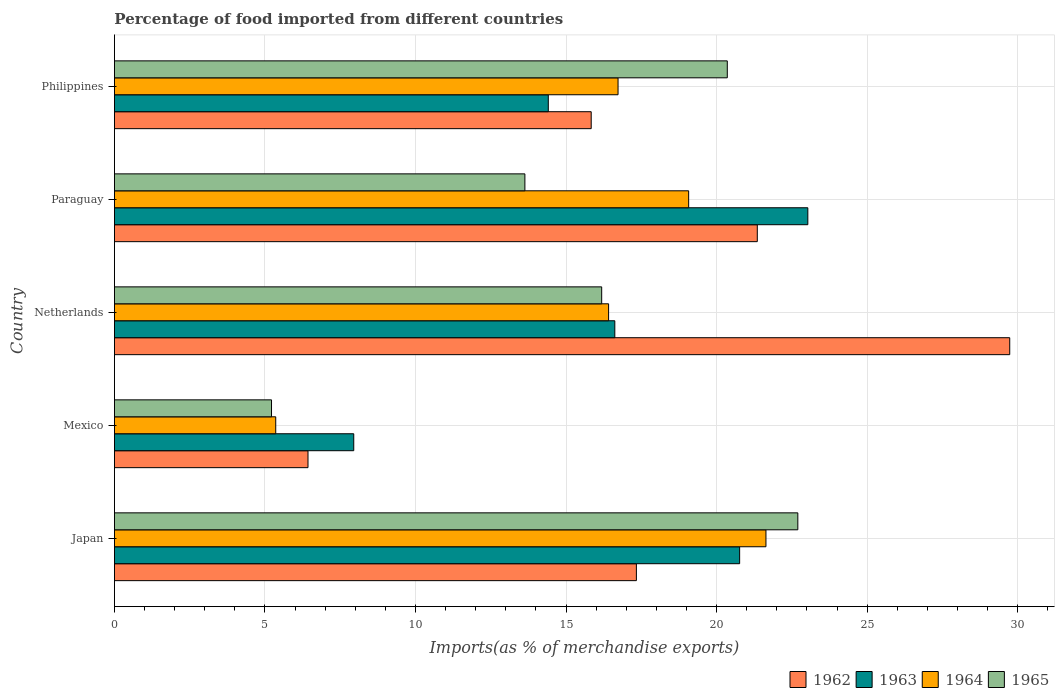How many different coloured bars are there?
Provide a succinct answer. 4. How many bars are there on the 2nd tick from the bottom?
Your response must be concise. 4. What is the label of the 4th group of bars from the top?
Your answer should be compact. Mexico. What is the percentage of imports to different countries in 1962 in Philippines?
Ensure brevity in your answer.  15.83. Across all countries, what is the maximum percentage of imports to different countries in 1965?
Offer a very short reply. 22.7. Across all countries, what is the minimum percentage of imports to different countries in 1965?
Offer a very short reply. 5.22. In which country was the percentage of imports to different countries in 1964 maximum?
Keep it short and to the point. Japan. What is the total percentage of imports to different countries in 1963 in the graph?
Make the answer very short. 82.77. What is the difference between the percentage of imports to different countries in 1964 in Japan and that in Netherlands?
Keep it short and to the point. 5.23. What is the difference between the percentage of imports to different countries in 1962 in Japan and the percentage of imports to different countries in 1965 in Netherlands?
Ensure brevity in your answer.  1.15. What is the average percentage of imports to different countries in 1962 per country?
Make the answer very short. 18.14. What is the difference between the percentage of imports to different countries in 1963 and percentage of imports to different countries in 1962 in Netherlands?
Offer a terse response. -13.12. In how many countries, is the percentage of imports to different countries in 1962 greater than 18 %?
Provide a short and direct response. 2. What is the ratio of the percentage of imports to different countries in 1962 in Japan to that in Mexico?
Provide a succinct answer. 2.7. What is the difference between the highest and the second highest percentage of imports to different countries in 1963?
Ensure brevity in your answer.  2.26. What is the difference between the highest and the lowest percentage of imports to different countries in 1965?
Provide a short and direct response. 17.48. In how many countries, is the percentage of imports to different countries in 1964 greater than the average percentage of imports to different countries in 1964 taken over all countries?
Your response must be concise. 4. Is the sum of the percentage of imports to different countries in 1962 in Japan and Netherlands greater than the maximum percentage of imports to different countries in 1963 across all countries?
Offer a terse response. Yes. Is it the case that in every country, the sum of the percentage of imports to different countries in 1962 and percentage of imports to different countries in 1963 is greater than the sum of percentage of imports to different countries in 1964 and percentage of imports to different countries in 1965?
Keep it short and to the point. No. What does the 2nd bar from the top in Philippines represents?
Provide a short and direct response. 1964. What does the 1st bar from the bottom in Mexico represents?
Provide a short and direct response. 1962. Is it the case that in every country, the sum of the percentage of imports to different countries in 1964 and percentage of imports to different countries in 1963 is greater than the percentage of imports to different countries in 1962?
Your answer should be very brief. Yes. What is the difference between two consecutive major ticks on the X-axis?
Ensure brevity in your answer.  5. Are the values on the major ticks of X-axis written in scientific E-notation?
Offer a terse response. No. Where does the legend appear in the graph?
Your answer should be very brief. Bottom right. How many legend labels are there?
Offer a terse response. 4. What is the title of the graph?
Give a very brief answer. Percentage of food imported from different countries. What is the label or title of the X-axis?
Your answer should be compact. Imports(as % of merchandise exports). What is the Imports(as % of merchandise exports) of 1962 in Japan?
Your answer should be compact. 17.34. What is the Imports(as % of merchandise exports) in 1963 in Japan?
Make the answer very short. 20.76. What is the Imports(as % of merchandise exports) in 1964 in Japan?
Make the answer very short. 21.64. What is the Imports(as % of merchandise exports) in 1965 in Japan?
Your response must be concise. 22.7. What is the Imports(as % of merchandise exports) of 1962 in Mexico?
Make the answer very short. 6.43. What is the Imports(as % of merchandise exports) in 1963 in Mexico?
Give a very brief answer. 7.95. What is the Imports(as % of merchandise exports) of 1964 in Mexico?
Provide a succinct answer. 5.36. What is the Imports(as % of merchandise exports) of 1965 in Mexico?
Your answer should be compact. 5.22. What is the Imports(as % of merchandise exports) in 1962 in Netherlands?
Offer a very short reply. 29.73. What is the Imports(as % of merchandise exports) of 1963 in Netherlands?
Provide a succinct answer. 16.62. What is the Imports(as % of merchandise exports) of 1964 in Netherlands?
Ensure brevity in your answer.  16.41. What is the Imports(as % of merchandise exports) of 1965 in Netherlands?
Offer a terse response. 16.18. What is the Imports(as % of merchandise exports) of 1962 in Paraguay?
Your response must be concise. 21.35. What is the Imports(as % of merchandise exports) of 1963 in Paraguay?
Make the answer very short. 23.03. What is the Imports(as % of merchandise exports) in 1964 in Paraguay?
Provide a short and direct response. 19.07. What is the Imports(as % of merchandise exports) in 1965 in Paraguay?
Give a very brief answer. 13.63. What is the Imports(as % of merchandise exports) of 1962 in Philippines?
Your answer should be compact. 15.83. What is the Imports(as % of merchandise exports) of 1963 in Philippines?
Provide a succinct answer. 14.41. What is the Imports(as % of merchandise exports) of 1964 in Philippines?
Your answer should be very brief. 16.73. What is the Imports(as % of merchandise exports) of 1965 in Philippines?
Keep it short and to the point. 20.35. Across all countries, what is the maximum Imports(as % of merchandise exports) of 1962?
Your answer should be compact. 29.73. Across all countries, what is the maximum Imports(as % of merchandise exports) of 1963?
Make the answer very short. 23.03. Across all countries, what is the maximum Imports(as % of merchandise exports) of 1964?
Give a very brief answer. 21.64. Across all countries, what is the maximum Imports(as % of merchandise exports) of 1965?
Give a very brief answer. 22.7. Across all countries, what is the minimum Imports(as % of merchandise exports) of 1962?
Offer a very short reply. 6.43. Across all countries, what is the minimum Imports(as % of merchandise exports) in 1963?
Provide a short and direct response. 7.95. Across all countries, what is the minimum Imports(as % of merchandise exports) of 1964?
Provide a short and direct response. 5.36. Across all countries, what is the minimum Imports(as % of merchandise exports) in 1965?
Make the answer very short. 5.22. What is the total Imports(as % of merchandise exports) in 1962 in the graph?
Provide a short and direct response. 90.68. What is the total Imports(as % of merchandise exports) in 1963 in the graph?
Offer a very short reply. 82.77. What is the total Imports(as % of merchandise exports) in 1964 in the graph?
Your answer should be compact. 79.21. What is the total Imports(as % of merchandise exports) in 1965 in the graph?
Make the answer very short. 78.08. What is the difference between the Imports(as % of merchandise exports) of 1962 in Japan and that in Mexico?
Ensure brevity in your answer.  10.91. What is the difference between the Imports(as % of merchandise exports) in 1963 in Japan and that in Mexico?
Ensure brevity in your answer.  12.82. What is the difference between the Imports(as % of merchandise exports) of 1964 in Japan and that in Mexico?
Give a very brief answer. 16.28. What is the difference between the Imports(as % of merchandise exports) in 1965 in Japan and that in Mexico?
Offer a very short reply. 17.48. What is the difference between the Imports(as % of merchandise exports) in 1962 in Japan and that in Netherlands?
Make the answer very short. -12.4. What is the difference between the Imports(as % of merchandise exports) in 1963 in Japan and that in Netherlands?
Offer a very short reply. 4.15. What is the difference between the Imports(as % of merchandise exports) of 1964 in Japan and that in Netherlands?
Provide a short and direct response. 5.23. What is the difference between the Imports(as % of merchandise exports) of 1965 in Japan and that in Netherlands?
Offer a terse response. 6.51. What is the difference between the Imports(as % of merchandise exports) in 1962 in Japan and that in Paraguay?
Provide a short and direct response. -4.02. What is the difference between the Imports(as % of merchandise exports) of 1963 in Japan and that in Paraguay?
Provide a short and direct response. -2.26. What is the difference between the Imports(as % of merchandise exports) of 1964 in Japan and that in Paraguay?
Make the answer very short. 2.57. What is the difference between the Imports(as % of merchandise exports) of 1965 in Japan and that in Paraguay?
Make the answer very short. 9.06. What is the difference between the Imports(as % of merchandise exports) in 1962 in Japan and that in Philippines?
Give a very brief answer. 1.5. What is the difference between the Imports(as % of merchandise exports) of 1963 in Japan and that in Philippines?
Your answer should be compact. 6.35. What is the difference between the Imports(as % of merchandise exports) in 1964 in Japan and that in Philippines?
Give a very brief answer. 4.91. What is the difference between the Imports(as % of merchandise exports) of 1965 in Japan and that in Philippines?
Offer a very short reply. 2.34. What is the difference between the Imports(as % of merchandise exports) of 1962 in Mexico and that in Netherlands?
Provide a short and direct response. -23.31. What is the difference between the Imports(as % of merchandise exports) of 1963 in Mexico and that in Netherlands?
Provide a short and direct response. -8.67. What is the difference between the Imports(as % of merchandise exports) in 1964 in Mexico and that in Netherlands?
Ensure brevity in your answer.  -11.05. What is the difference between the Imports(as % of merchandise exports) of 1965 in Mexico and that in Netherlands?
Your answer should be very brief. -10.97. What is the difference between the Imports(as % of merchandise exports) of 1962 in Mexico and that in Paraguay?
Provide a succinct answer. -14.92. What is the difference between the Imports(as % of merchandise exports) in 1963 in Mexico and that in Paraguay?
Your answer should be very brief. -15.08. What is the difference between the Imports(as % of merchandise exports) of 1964 in Mexico and that in Paraguay?
Make the answer very short. -13.71. What is the difference between the Imports(as % of merchandise exports) in 1965 in Mexico and that in Paraguay?
Make the answer very short. -8.42. What is the difference between the Imports(as % of merchandise exports) in 1962 in Mexico and that in Philippines?
Provide a short and direct response. -9.41. What is the difference between the Imports(as % of merchandise exports) of 1963 in Mexico and that in Philippines?
Keep it short and to the point. -6.46. What is the difference between the Imports(as % of merchandise exports) of 1964 in Mexico and that in Philippines?
Keep it short and to the point. -11.37. What is the difference between the Imports(as % of merchandise exports) in 1965 in Mexico and that in Philippines?
Your answer should be very brief. -15.14. What is the difference between the Imports(as % of merchandise exports) in 1962 in Netherlands and that in Paraguay?
Provide a short and direct response. 8.38. What is the difference between the Imports(as % of merchandise exports) in 1963 in Netherlands and that in Paraguay?
Provide a succinct answer. -6.41. What is the difference between the Imports(as % of merchandise exports) in 1964 in Netherlands and that in Paraguay?
Provide a succinct answer. -2.66. What is the difference between the Imports(as % of merchandise exports) of 1965 in Netherlands and that in Paraguay?
Provide a short and direct response. 2.55. What is the difference between the Imports(as % of merchandise exports) in 1962 in Netherlands and that in Philippines?
Your response must be concise. 13.9. What is the difference between the Imports(as % of merchandise exports) of 1963 in Netherlands and that in Philippines?
Offer a very short reply. 2.21. What is the difference between the Imports(as % of merchandise exports) in 1964 in Netherlands and that in Philippines?
Ensure brevity in your answer.  -0.31. What is the difference between the Imports(as % of merchandise exports) in 1965 in Netherlands and that in Philippines?
Provide a succinct answer. -4.17. What is the difference between the Imports(as % of merchandise exports) in 1962 in Paraguay and that in Philippines?
Ensure brevity in your answer.  5.52. What is the difference between the Imports(as % of merchandise exports) of 1963 in Paraguay and that in Philippines?
Keep it short and to the point. 8.62. What is the difference between the Imports(as % of merchandise exports) in 1964 in Paraguay and that in Philippines?
Provide a short and direct response. 2.35. What is the difference between the Imports(as % of merchandise exports) in 1965 in Paraguay and that in Philippines?
Give a very brief answer. -6.72. What is the difference between the Imports(as % of merchandise exports) of 1962 in Japan and the Imports(as % of merchandise exports) of 1963 in Mexico?
Your answer should be very brief. 9.39. What is the difference between the Imports(as % of merchandise exports) of 1962 in Japan and the Imports(as % of merchandise exports) of 1964 in Mexico?
Provide a short and direct response. 11.98. What is the difference between the Imports(as % of merchandise exports) in 1962 in Japan and the Imports(as % of merchandise exports) in 1965 in Mexico?
Offer a very short reply. 12.12. What is the difference between the Imports(as % of merchandise exports) in 1963 in Japan and the Imports(as % of merchandise exports) in 1964 in Mexico?
Provide a short and direct response. 15.41. What is the difference between the Imports(as % of merchandise exports) of 1963 in Japan and the Imports(as % of merchandise exports) of 1965 in Mexico?
Keep it short and to the point. 15.55. What is the difference between the Imports(as % of merchandise exports) in 1964 in Japan and the Imports(as % of merchandise exports) in 1965 in Mexico?
Your response must be concise. 16.42. What is the difference between the Imports(as % of merchandise exports) of 1962 in Japan and the Imports(as % of merchandise exports) of 1963 in Netherlands?
Offer a terse response. 0.72. What is the difference between the Imports(as % of merchandise exports) of 1962 in Japan and the Imports(as % of merchandise exports) of 1964 in Netherlands?
Your answer should be very brief. 0.92. What is the difference between the Imports(as % of merchandise exports) in 1962 in Japan and the Imports(as % of merchandise exports) in 1965 in Netherlands?
Offer a terse response. 1.15. What is the difference between the Imports(as % of merchandise exports) of 1963 in Japan and the Imports(as % of merchandise exports) of 1964 in Netherlands?
Provide a short and direct response. 4.35. What is the difference between the Imports(as % of merchandise exports) of 1963 in Japan and the Imports(as % of merchandise exports) of 1965 in Netherlands?
Provide a succinct answer. 4.58. What is the difference between the Imports(as % of merchandise exports) in 1964 in Japan and the Imports(as % of merchandise exports) in 1965 in Netherlands?
Make the answer very short. 5.46. What is the difference between the Imports(as % of merchandise exports) in 1962 in Japan and the Imports(as % of merchandise exports) in 1963 in Paraguay?
Ensure brevity in your answer.  -5.69. What is the difference between the Imports(as % of merchandise exports) of 1962 in Japan and the Imports(as % of merchandise exports) of 1964 in Paraguay?
Give a very brief answer. -1.74. What is the difference between the Imports(as % of merchandise exports) of 1962 in Japan and the Imports(as % of merchandise exports) of 1965 in Paraguay?
Ensure brevity in your answer.  3.7. What is the difference between the Imports(as % of merchandise exports) in 1963 in Japan and the Imports(as % of merchandise exports) in 1964 in Paraguay?
Your answer should be very brief. 1.69. What is the difference between the Imports(as % of merchandise exports) in 1963 in Japan and the Imports(as % of merchandise exports) in 1965 in Paraguay?
Offer a very short reply. 7.13. What is the difference between the Imports(as % of merchandise exports) of 1964 in Japan and the Imports(as % of merchandise exports) of 1965 in Paraguay?
Ensure brevity in your answer.  8.01. What is the difference between the Imports(as % of merchandise exports) in 1962 in Japan and the Imports(as % of merchandise exports) in 1963 in Philippines?
Offer a very short reply. 2.93. What is the difference between the Imports(as % of merchandise exports) in 1962 in Japan and the Imports(as % of merchandise exports) in 1964 in Philippines?
Offer a terse response. 0.61. What is the difference between the Imports(as % of merchandise exports) of 1962 in Japan and the Imports(as % of merchandise exports) of 1965 in Philippines?
Give a very brief answer. -3.02. What is the difference between the Imports(as % of merchandise exports) in 1963 in Japan and the Imports(as % of merchandise exports) in 1964 in Philippines?
Ensure brevity in your answer.  4.04. What is the difference between the Imports(as % of merchandise exports) of 1963 in Japan and the Imports(as % of merchandise exports) of 1965 in Philippines?
Provide a short and direct response. 0.41. What is the difference between the Imports(as % of merchandise exports) of 1964 in Japan and the Imports(as % of merchandise exports) of 1965 in Philippines?
Ensure brevity in your answer.  1.28. What is the difference between the Imports(as % of merchandise exports) of 1962 in Mexico and the Imports(as % of merchandise exports) of 1963 in Netherlands?
Provide a succinct answer. -10.19. What is the difference between the Imports(as % of merchandise exports) of 1962 in Mexico and the Imports(as % of merchandise exports) of 1964 in Netherlands?
Your response must be concise. -9.98. What is the difference between the Imports(as % of merchandise exports) of 1962 in Mexico and the Imports(as % of merchandise exports) of 1965 in Netherlands?
Give a very brief answer. -9.75. What is the difference between the Imports(as % of merchandise exports) of 1963 in Mexico and the Imports(as % of merchandise exports) of 1964 in Netherlands?
Ensure brevity in your answer.  -8.46. What is the difference between the Imports(as % of merchandise exports) of 1963 in Mexico and the Imports(as % of merchandise exports) of 1965 in Netherlands?
Provide a short and direct response. -8.23. What is the difference between the Imports(as % of merchandise exports) in 1964 in Mexico and the Imports(as % of merchandise exports) in 1965 in Netherlands?
Ensure brevity in your answer.  -10.83. What is the difference between the Imports(as % of merchandise exports) in 1962 in Mexico and the Imports(as % of merchandise exports) in 1963 in Paraguay?
Provide a succinct answer. -16.6. What is the difference between the Imports(as % of merchandise exports) of 1962 in Mexico and the Imports(as % of merchandise exports) of 1964 in Paraguay?
Keep it short and to the point. -12.64. What is the difference between the Imports(as % of merchandise exports) of 1962 in Mexico and the Imports(as % of merchandise exports) of 1965 in Paraguay?
Ensure brevity in your answer.  -7.2. What is the difference between the Imports(as % of merchandise exports) of 1963 in Mexico and the Imports(as % of merchandise exports) of 1964 in Paraguay?
Make the answer very short. -11.12. What is the difference between the Imports(as % of merchandise exports) in 1963 in Mexico and the Imports(as % of merchandise exports) in 1965 in Paraguay?
Your answer should be very brief. -5.68. What is the difference between the Imports(as % of merchandise exports) of 1964 in Mexico and the Imports(as % of merchandise exports) of 1965 in Paraguay?
Your answer should be compact. -8.27. What is the difference between the Imports(as % of merchandise exports) in 1962 in Mexico and the Imports(as % of merchandise exports) in 1963 in Philippines?
Offer a terse response. -7.98. What is the difference between the Imports(as % of merchandise exports) in 1962 in Mexico and the Imports(as % of merchandise exports) in 1964 in Philippines?
Your response must be concise. -10.3. What is the difference between the Imports(as % of merchandise exports) in 1962 in Mexico and the Imports(as % of merchandise exports) in 1965 in Philippines?
Keep it short and to the point. -13.93. What is the difference between the Imports(as % of merchandise exports) in 1963 in Mexico and the Imports(as % of merchandise exports) in 1964 in Philippines?
Your answer should be very brief. -8.78. What is the difference between the Imports(as % of merchandise exports) of 1963 in Mexico and the Imports(as % of merchandise exports) of 1965 in Philippines?
Ensure brevity in your answer.  -12.41. What is the difference between the Imports(as % of merchandise exports) of 1964 in Mexico and the Imports(as % of merchandise exports) of 1965 in Philippines?
Offer a terse response. -15. What is the difference between the Imports(as % of merchandise exports) in 1962 in Netherlands and the Imports(as % of merchandise exports) in 1963 in Paraguay?
Keep it short and to the point. 6.71. What is the difference between the Imports(as % of merchandise exports) of 1962 in Netherlands and the Imports(as % of merchandise exports) of 1964 in Paraguay?
Keep it short and to the point. 10.66. What is the difference between the Imports(as % of merchandise exports) in 1962 in Netherlands and the Imports(as % of merchandise exports) in 1965 in Paraguay?
Provide a succinct answer. 16.1. What is the difference between the Imports(as % of merchandise exports) of 1963 in Netherlands and the Imports(as % of merchandise exports) of 1964 in Paraguay?
Provide a succinct answer. -2.45. What is the difference between the Imports(as % of merchandise exports) of 1963 in Netherlands and the Imports(as % of merchandise exports) of 1965 in Paraguay?
Provide a succinct answer. 2.99. What is the difference between the Imports(as % of merchandise exports) in 1964 in Netherlands and the Imports(as % of merchandise exports) in 1965 in Paraguay?
Offer a very short reply. 2.78. What is the difference between the Imports(as % of merchandise exports) of 1962 in Netherlands and the Imports(as % of merchandise exports) of 1963 in Philippines?
Your answer should be very brief. 15.32. What is the difference between the Imports(as % of merchandise exports) of 1962 in Netherlands and the Imports(as % of merchandise exports) of 1964 in Philippines?
Your answer should be very brief. 13.01. What is the difference between the Imports(as % of merchandise exports) of 1962 in Netherlands and the Imports(as % of merchandise exports) of 1965 in Philippines?
Your answer should be very brief. 9.38. What is the difference between the Imports(as % of merchandise exports) in 1963 in Netherlands and the Imports(as % of merchandise exports) in 1964 in Philippines?
Make the answer very short. -0.11. What is the difference between the Imports(as % of merchandise exports) in 1963 in Netherlands and the Imports(as % of merchandise exports) in 1965 in Philippines?
Provide a short and direct response. -3.74. What is the difference between the Imports(as % of merchandise exports) in 1964 in Netherlands and the Imports(as % of merchandise exports) in 1965 in Philippines?
Keep it short and to the point. -3.94. What is the difference between the Imports(as % of merchandise exports) in 1962 in Paraguay and the Imports(as % of merchandise exports) in 1963 in Philippines?
Keep it short and to the point. 6.94. What is the difference between the Imports(as % of merchandise exports) of 1962 in Paraguay and the Imports(as % of merchandise exports) of 1964 in Philippines?
Your answer should be very brief. 4.62. What is the difference between the Imports(as % of merchandise exports) in 1963 in Paraguay and the Imports(as % of merchandise exports) in 1964 in Philippines?
Ensure brevity in your answer.  6.3. What is the difference between the Imports(as % of merchandise exports) of 1963 in Paraguay and the Imports(as % of merchandise exports) of 1965 in Philippines?
Offer a terse response. 2.67. What is the difference between the Imports(as % of merchandise exports) in 1964 in Paraguay and the Imports(as % of merchandise exports) in 1965 in Philippines?
Provide a short and direct response. -1.28. What is the average Imports(as % of merchandise exports) in 1962 per country?
Provide a succinct answer. 18.14. What is the average Imports(as % of merchandise exports) of 1963 per country?
Your answer should be compact. 16.55. What is the average Imports(as % of merchandise exports) of 1964 per country?
Your answer should be compact. 15.84. What is the average Imports(as % of merchandise exports) of 1965 per country?
Offer a very short reply. 15.62. What is the difference between the Imports(as % of merchandise exports) in 1962 and Imports(as % of merchandise exports) in 1963 in Japan?
Offer a very short reply. -3.43. What is the difference between the Imports(as % of merchandise exports) in 1962 and Imports(as % of merchandise exports) in 1964 in Japan?
Your answer should be compact. -4.3. What is the difference between the Imports(as % of merchandise exports) in 1962 and Imports(as % of merchandise exports) in 1965 in Japan?
Offer a very short reply. -5.36. What is the difference between the Imports(as % of merchandise exports) of 1963 and Imports(as % of merchandise exports) of 1964 in Japan?
Provide a succinct answer. -0.87. What is the difference between the Imports(as % of merchandise exports) of 1963 and Imports(as % of merchandise exports) of 1965 in Japan?
Offer a very short reply. -1.93. What is the difference between the Imports(as % of merchandise exports) in 1964 and Imports(as % of merchandise exports) in 1965 in Japan?
Keep it short and to the point. -1.06. What is the difference between the Imports(as % of merchandise exports) of 1962 and Imports(as % of merchandise exports) of 1963 in Mexico?
Offer a terse response. -1.52. What is the difference between the Imports(as % of merchandise exports) of 1962 and Imports(as % of merchandise exports) of 1964 in Mexico?
Your answer should be compact. 1.07. What is the difference between the Imports(as % of merchandise exports) in 1962 and Imports(as % of merchandise exports) in 1965 in Mexico?
Offer a very short reply. 1.21. What is the difference between the Imports(as % of merchandise exports) of 1963 and Imports(as % of merchandise exports) of 1964 in Mexico?
Ensure brevity in your answer.  2.59. What is the difference between the Imports(as % of merchandise exports) in 1963 and Imports(as % of merchandise exports) in 1965 in Mexico?
Keep it short and to the point. 2.73. What is the difference between the Imports(as % of merchandise exports) of 1964 and Imports(as % of merchandise exports) of 1965 in Mexico?
Your answer should be very brief. 0.14. What is the difference between the Imports(as % of merchandise exports) of 1962 and Imports(as % of merchandise exports) of 1963 in Netherlands?
Ensure brevity in your answer.  13.12. What is the difference between the Imports(as % of merchandise exports) in 1962 and Imports(as % of merchandise exports) in 1964 in Netherlands?
Keep it short and to the point. 13.32. What is the difference between the Imports(as % of merchandise exports) in 1962 and Imports(as % of merchandise exports) in 1965 in Netherlands?
Offer a very short reply. 13.55. What is the difference between the Imports(as % of merchandise exports) in 1963 and Imports(as % of merchandise exports) in 1964 in Netherlands?
Ensure brevity in your answer.  0.21. What is the difference between the Imports(as % of merchandise exports) in 1963 and Imports(as % of merchandise exports) in 1965 in Netherlands?
Offer a very short reply. 0.44. What is the difference between the Imports(as % of merchandise exports) in 1964 and Imports(as % of merchandise exports) in 1965 in Netherlands?
Your answer should be very brief. 0.23. What is the difference between the Imports(as % of merchandise exports) of 1962 and Imports(as % of merchandise exports) of 1963 in Paraguay?
Offer a terse response. -1.68. What is the difference between the Imports(as % of merchandise exports) of 1962 and Imports(as % of merchandise exports) of 1964 in Paraguay?
Offer a terse response. 2.28. What is the difference between the Imports(as % of merchandise exports) of 1962 and Imports(as % of merchandise exports) of 1965 in Paraguay?
Provide a succinct answer. 7.72. What is the difference between the Imports(as % of merchandise exports) of 1963 and Imports(as % of merchandise exports) of 1964 in Paraguay?
Give a very brief answer. 3.96. What is the difference between the Imports(as % of merchandise exports) in 1963 and Imports(as % of merchandise exports) in 1965 in Paraguay?
Make the answer very short. 9.4. What is the difference between the Imports(as % of merchandise exports) in 1964 and Imports(as % of merchandise exports) in 1965 in Paraguay?
Keep it short and to the point. 5.44. What is the difference between the Imports(as % of merchandise exports) of 1962 and Imports(as % of merchandise exports) of 1963 in Philippines?
Your response must be concise. 1.43. What is the difference between the Imports(as % of merchandise exports) of 1962 and Imports(as % of merchandise exports) of 1964 in Philippines?
Offer a terse response. -0.89. What is the difference between the Imports(as % of merchandise exports) in 1962 and Imports(as % of merchandise exports) in 1965 in Philippines?
Your answer should be compact. -4.52. What is the difference between the Imports(as % of merchandise exports) of 1963 and Imports(as % of merchandise exports) of 1964 in Philippines?
Offer a very short reply. -2.32. What is the difference between the Imports(as % of merchandise exports) of 1963 and Imports(as % of merchandise exports) of 1965 in Philippines?
Your response must be concise. -5.94. What is the difference between the Imports(as % of merchandise exports) in 1964 and Imports(as % of merchandise exports) in 1965 in Philippines?
Give a very brief answer. -3.63. What is the ratio of the Imports(as % of merchandise exports) of 1962 in Japan to that in Mexico?
Give a very brief answer. 2.7. What is the ratio of the Imports(as % of merchandise exports) in 1963 in Japan to that in Mexico?
Offer a terse response. 2.61. What is the ratio of the Imports(as % of merchandise exports) of 1964 in Japan to that in Mexico?
Provide a succinct answer. 4.04. What is the ratio of the Imports(as % of merchandise exports) in 1965 in Japan to that in Mexico?
Make the answer very short. 4.35. What is the ratio of the Imports(as % of merchandise exports) in 1962 in Japan to that in Netherlands?
Your answer should be very brief. 0.58. What is the ratio of the Imports(as % of merchandise exports) in 1963 in Japan to that in Netherlands?
Your response must be concise. 1.25. What is the ratio of the Imports(as % of merchandise exports) of 1964 in Japan to that in Netherlands?
Offer a terse response. 1.32. What is the ratio of the Imports(as % of merchandise exports) of 1965 in Japan to that in Netherlands?
Provide a succinct answer. 1.4. What is the ratio of the Imports(as % of merchandise exports) of 1962 in Japan to that in Paraguay?
Keep it short and to the point. 0.81. What is the ratio of the Imports(as % of merchandise exports) of 1963 in Japan to that in Paraguay?
Offer a terse response. 0.9. What is the ratio of the Imports(as % of merchandise exports) of 1964 in Japan to that in Paraguay?
Offer a terse response. 1.13. What is the ratio of the Imports(as % of merchandise exports) of 1965 in Japan to that in Paraguay?
Your response must be concise. 1.67. What is the ratio of the Imports(as % of merchandise exports) in 1962 in Japan to that in Philippines?
Your response must be concise. 1.09. What is the ratio of the Imports(as % of merchandise exports) in 1963 in Japan to that in Philippines?
Make the answer very short. 1.44. What is the ratio of the Imports(as % of merchandise exports) in 1964 in Japan to that in Philippines?
Provide a short and direct response. 1.29. What is the ratio of the Imports(as % of merchandise exports) in 1965 in Japan to that in Philippines?
Offer a terse response. 1.12. What is the ratio of the Imports(as % of merchandise exports) in 1962 in Mexico to that in Netherlands?
Your answer should be compact. 0.22. What is the ratio of the Imports(as % of merchandise exports) of 1963 in Mexico to that in Netherlands?
Provide a short and direct response. 0.48. What is the ratio of the Imports(as % of merchandise exports) in 1964 in Mexico to that in Netherlands?
Offer a terse response. 0.33. What is the ratio of the Imports(as % of merchandise exports) in 1965 in Mexico to that in Netherlands?
Offer a very short reply. 0.32. What is the ratio of the Imports(as % of merchandise exports) in 1962 in Mexico to that in Paraguay?
Your response must be concise. 0.3. What is the ratio of the Imports(as % of merchandise exports) in 1963 in Mexico to that in Paraguay?
Give a very brief answer. 0.35. What is the ratio of the Imports(as % of merchandise exports) of 1964 in Mexico to that in Paraguay?
Give a very brief answer. 0.28. What is the ratio of the Imports(as % of merchandise exports) of 1965 in Mexico to that in Paraguay?
Your response must be concise. 0.38. What is the ratio of the Imports(as % of merchandise exports) of 1962 in Mexico to that in Philippines?
Offer a terse response. 0.41. What is the ratio of the Imports(as % of merchandise exports) in 1963 in Mexico to that in Philippines?
Your response must be concise. 0.55. What is the ratio of the Imports(as % of merchandise exports) of 1964 in Mexico to that in Philippines?
Offer a very short reply. 0.32. What is the ratio of the Imports(as % of merchandise exports) of 1965 in Mexico to that in Philippines?
Provide a succinct answer. 0.26. What is the ratio of the Imports(as % of merchandise exports) in 1962 in Netherlands to that in Paraguay?
Keep it short and to the point. 1.39. What is the ratio of the Imports(as % of merchandise exports) of 1963 in Netherlands to that in Paraguay?
Offer a very short reply. 0.72. What is the ratio of the Imports(as % of merchandise exports) in 1964 in Netherlands to that in Paraguay?
Give a very brief answer. 0.86. What is the ratio of the Imports(as % of merchandise exports) in 1965 in Netherlands to that in Paraguay?
Give a very brief answer. 1.19. What is the ratio of the Imports(as % of merchandise exports) in 1962 in Netherlands to that in Philippines?
Make the answer very short. 1.88. What is the ratio of the Imports(as % of merchandise exports) of 1963 in Netherlands to that in Philippines?
Your response must be concise. 1.15. What is the ratio of the Imports(as % of merchandise exports) of 1964 in Netherlands to that in Philippines?
Keep it short and to the point. 0.98. What is the ratio of the Imports(as % of merchandise exports) in 1965 in Netherlands to that in Philippines?
Offer a terse response. 0.8. What is the ratio of the Imports(as % of merchandise exports) of 1962 in Paraguay to that in Philippines?
Your answer should be very brief. 1.35. What is the ratio of the Imports(as % of merchandise exports) of 1963 in Paraguay to that in Philippines?
Offer a very short reply. 1.6. What is the ratio of the Imports(as % of merchandise exports) in 1964 in Paraguay to that in Philippines?
Offer a terse response. 1.14. What is the ratio of the Imports(as % of merchandise exports) in 1965 in Paraguay to that in Philippines?
Ensure brevity in your answer.  0.67. What is the difference between the highest and the second highest Imports(as % of merchandise exports) in 1962?
Your response must be concise. 8.38. What is the difference between the highest and the second highest Imports(as % of merchandise exports) of 1963?
Your answer should be compact. 2.26. What is the difference between the highest and the second highest Imports(as % of merchandise exports) in 1964?
Your answer should be very brief. 2.57. What is the difference between the highest and the second highest Imports(as % of merchandise exports) of 1965?
Your answer should be very brief. 2.34. What is the difference between the highest and the lowest Imports(as % of merchandise exports) in 1962?
Make the answer very short. 23.31. What is the difference between the highest and the lowest Imports(as % of merchandise exports) in 1963?
Make the answer very short. 15.08. What is the difference between the highest and the lowest Imports(as % of merchandise exports) of 1964?
Offer a very short reply. 16.28. What is the difference between the highest and the lowest Imports(as % of merchandise exports) in 1965?
Your answer should be very brief. 17.48. 